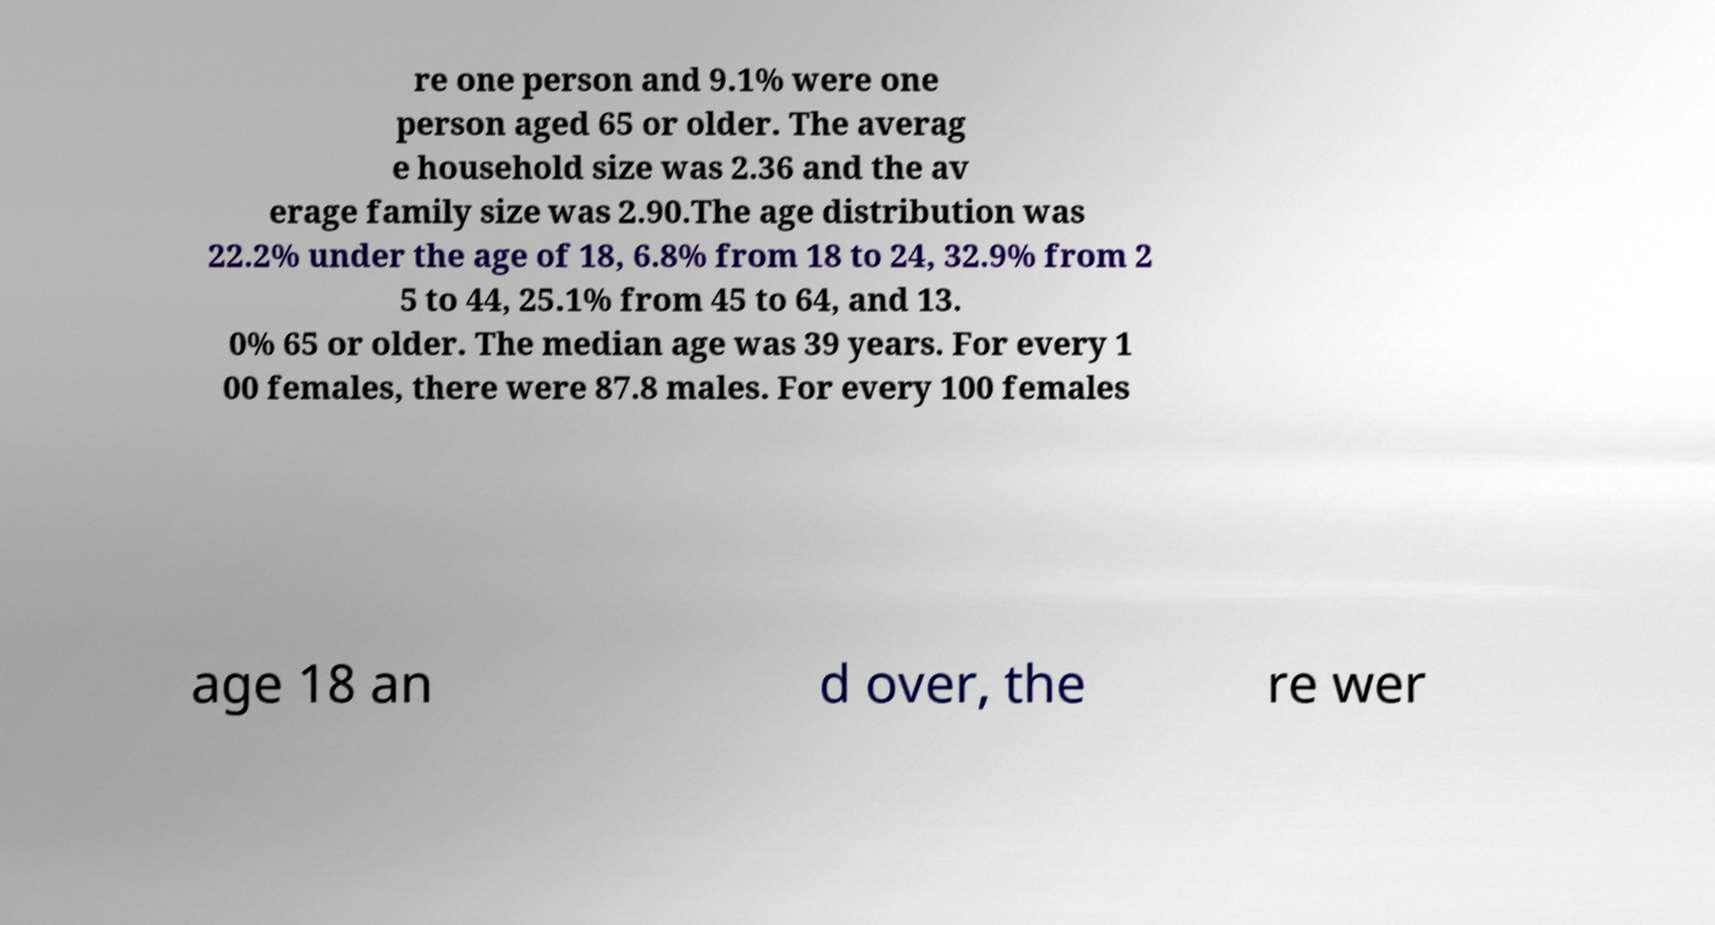Could you extract and type out the text from this image? re one person and 9.1% were one person aged 65 or older. The averag e household size was 2.36 and the av erage family size was 2.90.The age distribution was 22.2% under the age of 18, 6.8% from 18 to 24, 32.9% from 2 5 to 44, 25.1% from 45 to 64, and 13. 0% 65 or older. The median age was 39 years. For every 1 00 females, there were 87.8 males. For every 100 females age 18 an d over, the re wer 